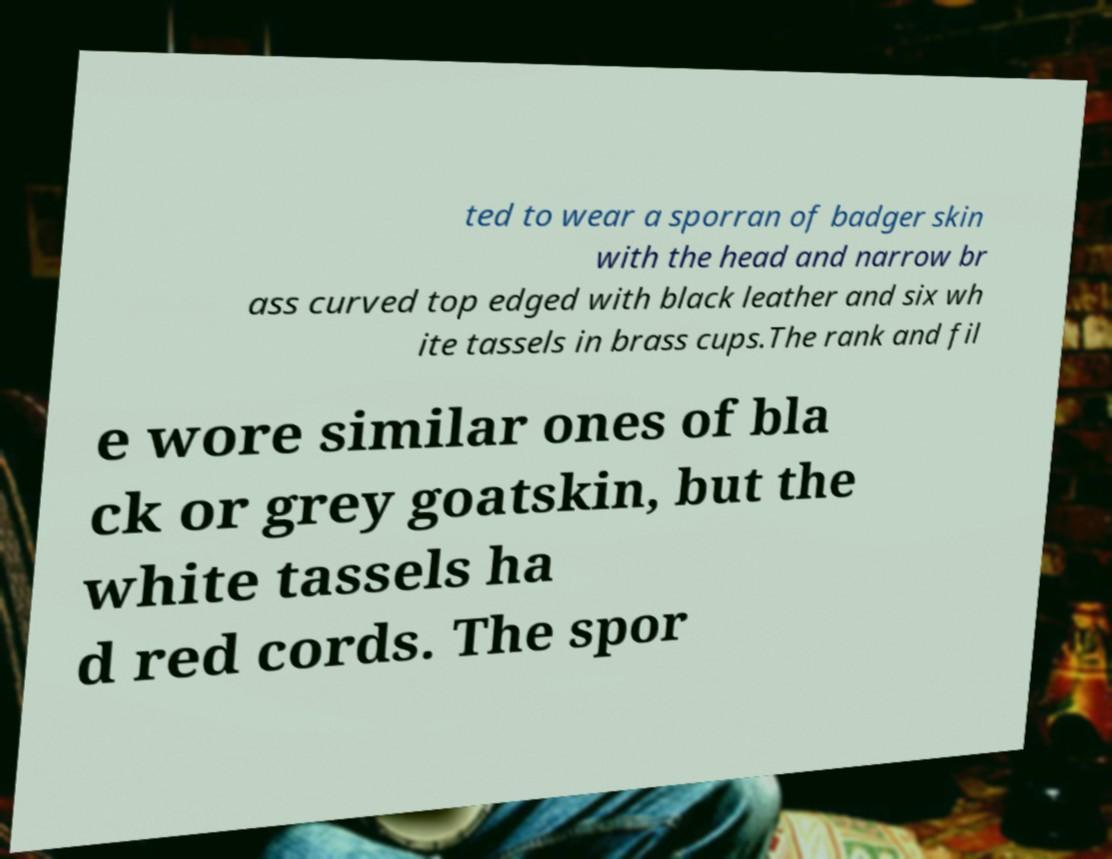Could you extract and type out the text from this image? ted to wear a sporran of badger skin with the head and narrow br ass curved top edged with black leather and six wh ite tassels in brass cups.The rank and fil e wore similar ones of bla ck or grey goatskin, but the white tassels ha d red cords. The spor 